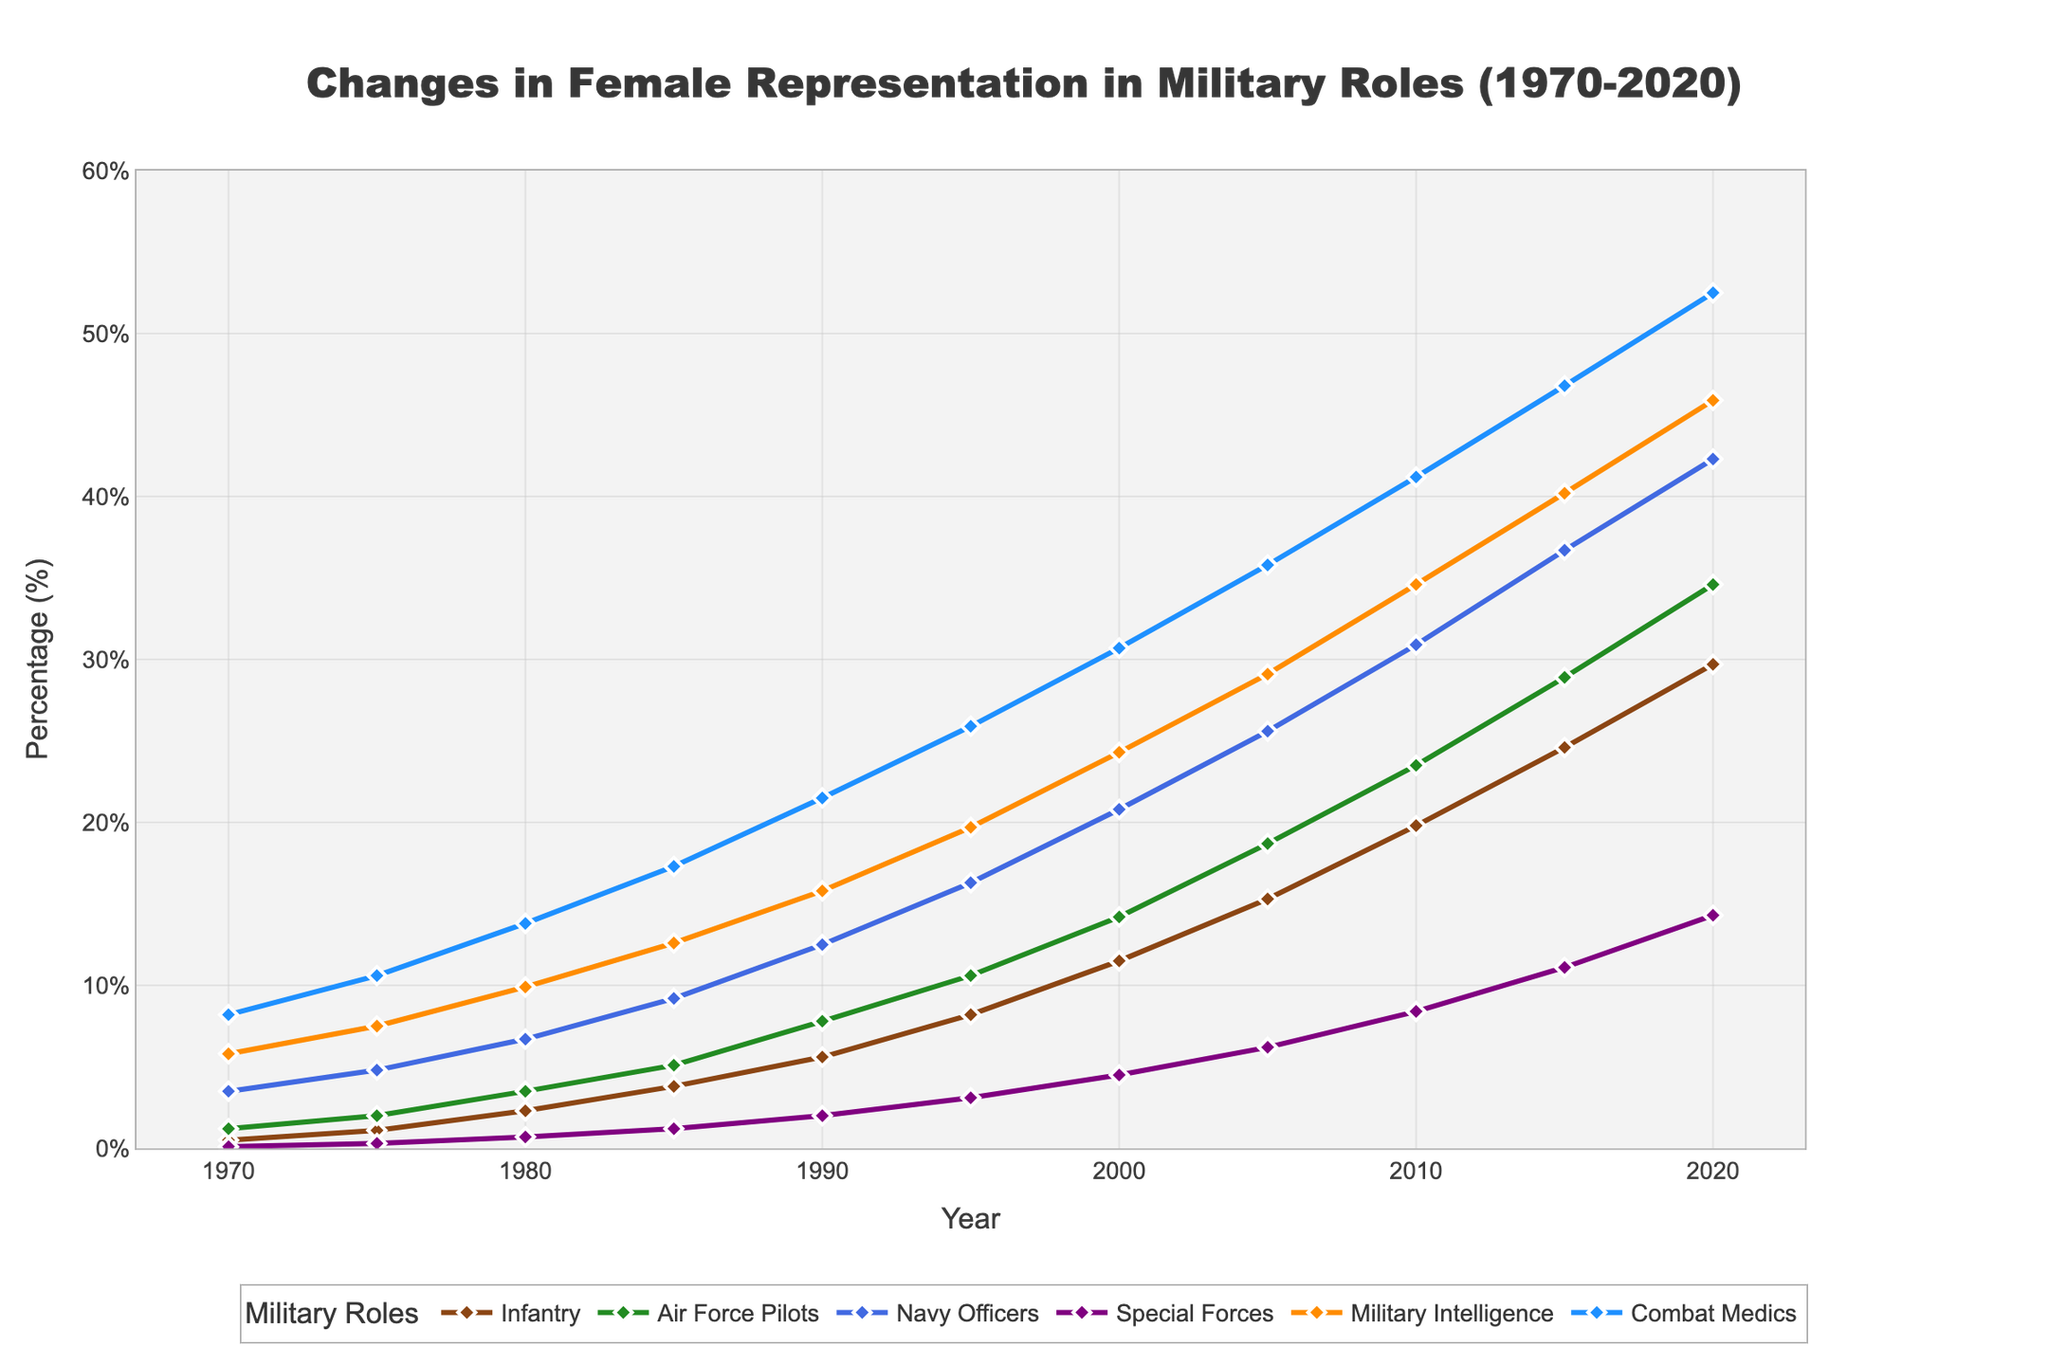What year did the percentage of female Air Force pilots first exceed 20%? In the figure, trace the line representing Air Force Pilots and observe when its values surpass 20%. This happens between 2000 and 2005.
Answer: 2005 Which role had the highest percentage of female representation in 2020? Locate the endpoints of each line at the year 2020, identifying which role's point is the highest. Combat Medics had the highest value, around 52.5%.
Answer: Combat Medics How much did female representation in the Special Forces increase from 1980 to 2020? Subtract the percentage in 1980 from that in 2020 for the Special Forces. The values are 14.3 in 2020 and 0.7 in 1980, leading to an increase of 13.6.
Answer: 13.6% Which two roles had the closest female representation percentages in 1985? Compare the 1985 data points on the chart and identify the two lines closest to each other. Infantry and Air Force Pilots had values of 3.8% and 5.1%, respectively, with a difference of 1.3%.
Answer: Infantry and Air Force Pilots What is the average percentage of female Navy Officers over the five decades depicted? Sum up the percentages of female Navy Officers for each year and divide by the number of decades (11). The sum is 216.7; thus, the average is 216.7/11 ≈ 19.7%.
Answer: 19.7% How does the growth of female representation in Military Intelligence from 1970 to 1980 compare to that of Combat Medics in the same period? Calculate the difference in percentage values for Military Intelligence (9.9-5.8) and Combat Medics (13.8-8.2), resulting in 4.1% and 5.6%, respectively.
Answer: Combat Medics had a higher growth In which year did female Infantry representation reach 15%? Look at the line representing Infantry and find the year where it crosses the 15% mark, which occurs in 2005.
Answer: 2005 By how much did the percentage of female Air Force Pilots increase from 2000 to 2010? Subtract the percentage in 2000 from that in 2010 for Air Force Pilots. The values are 23.5 in 2010 and 14.2 in 2000, leading to an increase of 9.3.
Answer: 9.3% 